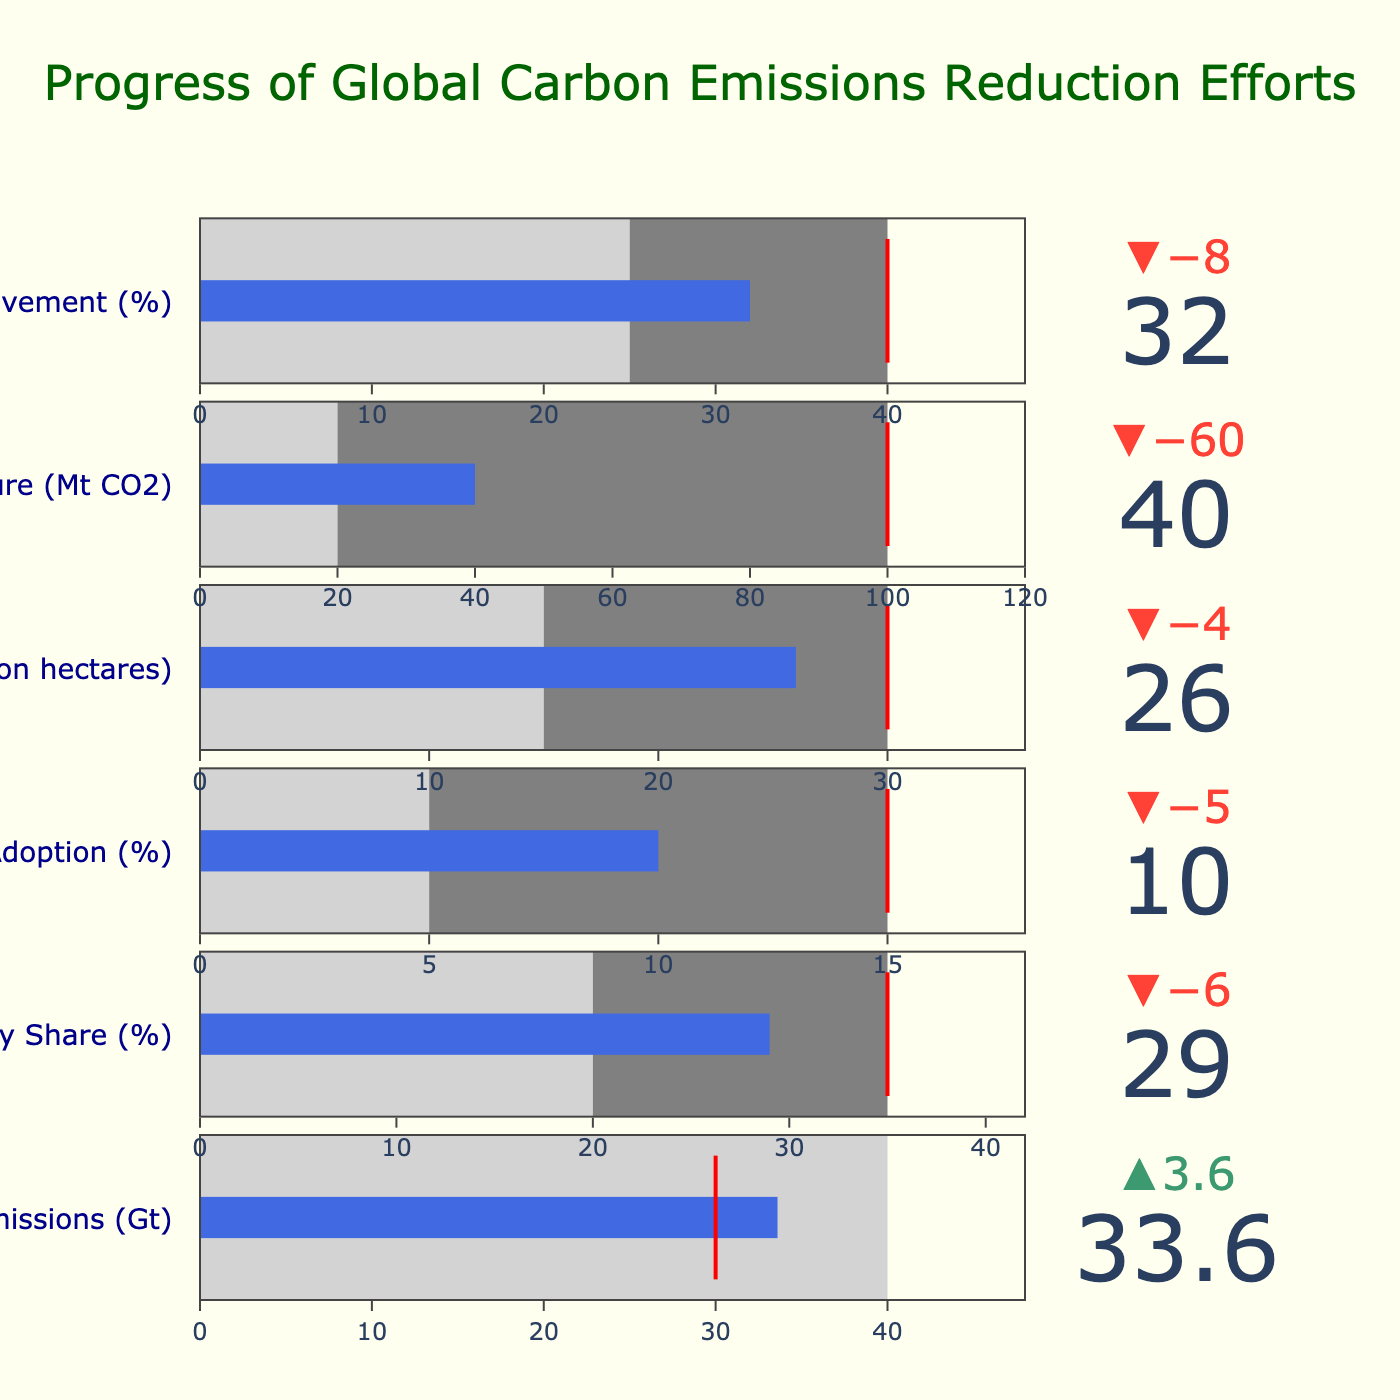What is the target value for Global CO2 Emissions? The target value for Global CO2 Emissions is directly provided in the data and visually indicated by the red line in the chart. It is 30 Gt.
Answer: 30 Gt In which category does the actual value exceed both the target and the benchmark? We need to check for each category in the chart where the actual value is higher than both the target and the benchmark. For carbon capture, the actual value is 40 Mt, which is higher than both the target of 20 Mt and the benchmark of 20 Mt.
Answer: Carbon Capture What is the difference between the actual and target values for Renewable Energy Share? Subtract the target value (35%) from the actual value (29%) for Renewable Energy Share. 29% - 35% = -6%.
Answer: -6% Which category shows the smallest gap between the actual and benchmark values? To find this, we calculate the differences between the actual and benchmark values for all categories. The smallest difference is for Renewable Energy Share (29% - 20% = 9%).
Answer: Renewable Energy Share How many categories have actual values above the benchmark? There are six categories. We need to count how many of these have actual values greater than their benchmarks. Global CO2 Emissions, Renewable Energy Share, Electric Vehicle Adoption, Reforestation, Carbon Capture, and Energy Efficiency Improvement all have actual values exceeding the benchmarks.
Answer: 6 For which category do the actual values fall short of the target? Compare the actual to the target values in each category. Global CO2 Emissions, Renewable Energy Share, Electric Vehicle Adoption, Reforestation, and Carbon Capture all have actual values which are less than their targets.
Answer: 5 categories What is the actual value for Reforestation, and how does it compare to its target and benchmark? The actual reforestation value is 26 million hectares. The target is 30 million hectares, and the benchmark is 15 million hectares. The actual value is less than the target but greater than the benchmark.
Answer: 26 million ha, less than target, more than benchmark Are there any categories where the actual value is exactly on the target? Visually inspect the chart for any category where the bar indicating the actual value aligns exactly with the red line showing the target value. None of the categories have an actual value exactly equal to the target.
Answer: None What percentage of targets have been met across all categories (count of categories meeting targets / total categories)? We need to determine for how many categories the actual value meets or exceeds the target and divide by the total number of categories. None of the categories meet their target values. Percentage = (0/6) * 100 = 0%.
Answer: 0% 